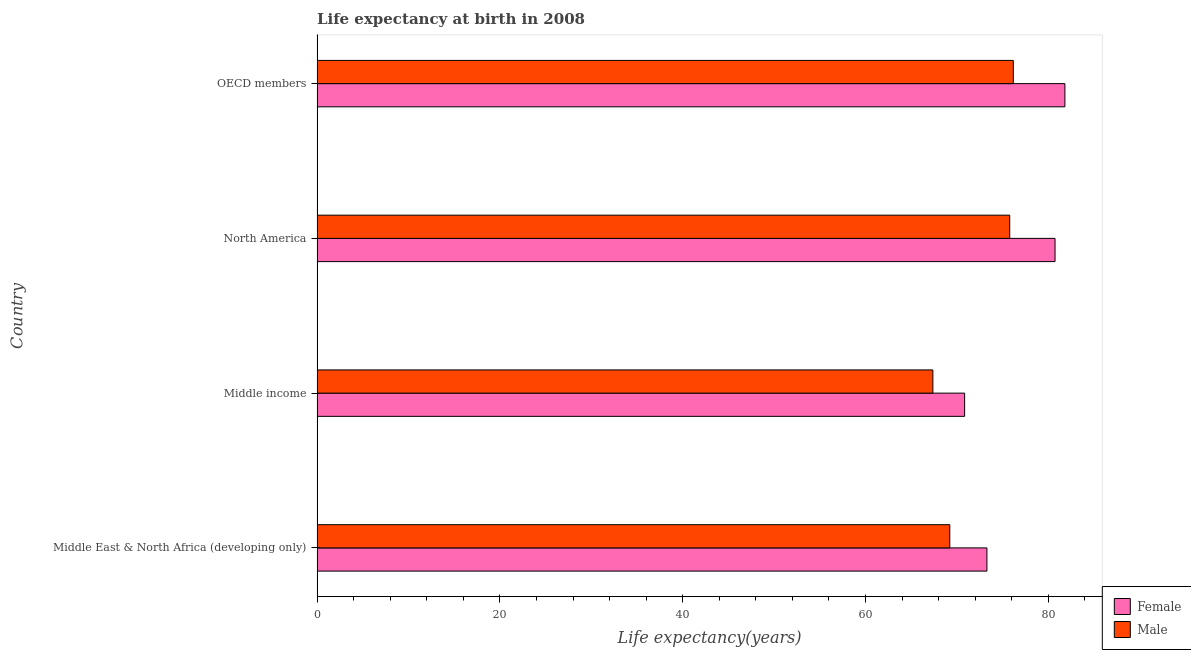How many different coloured bars are there?
Your response must be concise. 2. What is the label of the 2nd group of bars from the top?
Your answer should be very brief. North America. In how many cases, is the number of bars for a given country not equal to the number of legend labels?
Keep it short and to the point. 0. What is the life expectancy(male) in North America?
Your answer should be very brief. 75.78. Across all countries, what is the maximum life expectancy(male)?
Provide a succinct answer. 76.17. Across all countries, what is the minimum life expectancy(female)?
Ensure brevity in your answer.  70.84. In which country was the life expectancy(female) maximum?
Offer a very short reply. OECD members. In which country was the life expectancy(female) minimum?
Ensure brevity in your answer.  Middle income. What is the total life expectancy(female) in the graph?
Ensure brevity in your answer.  306.67. What is the difference between the life expectancy(male) in North America and that in OECD members?
Give a very brief answer. -0.39. What is the difference between the life expectancy(female) in OECD members and the life expectancy(male) in North America?
Your answer should be compact. 6.04. What is the average life expectancy(female) per country?
Ensure brevity in your answer.  76.67. What is the difference between the life expectancy(male) and life expectancy(female) in OECD members?
Keep it short and to the point. -5.65. In how many countries, is the life expectancy(female) greater than 36 years?
Your answer should be very brief. 4. What is the ratio of the life expectancy(male) in Middle income to that in OECD members?
Ensure brevity in your answer.  0.88. Is the life expectancy(male) in Middle East & North Africa (developing only) less than that in Middle income?
Offer a very short reply. No. What is the difference between the highest and the second highest life expectancy(male)?
Your response must be concise. 0.39. What does the 1st bar from the top in Middle income represents?
Make the answer very short. Male. Are all the bars in the graph horizontal?
Your answer should be compact. Yes. How many countries are there in the graph?
Offer a terse response. 4. Are the values on the major ticks of X-axis written in scientific E-notation?
Make the answer very short. No. Does the graph contain grids?
Your answer should be very brief. No. Where does the legend appear in the graph?
Make the answer very short. Bottom right. How many legend labels are there?
Provide a short and direct response. 2. What is the title of the graph?
Your answer should be compact. Life expectancy at birth in 2008. What is the label or title of the X-axis?
Offer a very short reply. Life expectancy(years). What is the Life expectancy(years) in Female in Middle East & North Africa (developing only)?
Provide a succinct answer. 73.28. What is the Life expectancy(years) in Male in Middle East & North Africa (developing only)?
Provide a succinct answer. 69.22. What is the Life expectancy(years) in Female in Middle income?
Your response must be concise. 70.84. What is the Life expectancy(years) of Male in Middle income?
Offer a terse response. 67.37. What is the Life expectancy(years) of Female in North America?
Ensure brevity in your answer.  80.73. What is the Life expectancy(years) in Male in North America?
Ensure brevity in your answer.  75.78. What is the Life expectancy(years) of Female in OECD members?
Offer a very short reply. 81.81. What is the Life expectancy(years) of Male in OECD members?
Your response must be concise. 76.17. Across all countries, what is the maximum Life expectancy(years) in Female?
Your answer should be very brief. 81.81. Across all countries, what is the maximum Life expectancy(years) in Male?
Make the answer very short. 76.17. Across all countries, what is the minimum Life expectancy(years) of Female?
Ensure brevity in your answer.  70.84. Across all countries, what is the minimum Life expectancy(years) of Male?
Your answer should be very brief. 67.37. What is the total Life expectancy(years) of Female in the graph?
Make the answer very short. 306.67. What is the total Life expectancy(years) in Male in the graph?
Your answer should be compact. 288.54. What is the difference between the Life expectancy(years) of Female in Middle East & North Africa (developing only) and that in Middle income?
Your answer should be very brief. 2.44. What is the difference between the Life expectancy(years) of Male in Middle East & North Africa (developing only) and that in Middle income?
Provide a short and direct response. 1.85. What is the difference between the Life expectancy(years) in Female in Middle East & North Africa (developing only) and that in North America?
Your answer should be compact. -7.45. What is the difference between the Life expectancy(years) of Male in Middle East & North Africa (developing only) and that in North America?
Keep it short and to the point. -6.56. What is the difference between the Life expectancy(years) of Female in Middle East & North Africa (developing only) and that in OECD members?
Keep it short and to the point. -8.53. What is the difference between the Life expectancy(years) of Male in Middle East & North Africa (developing only) and that in OECD members?
Ensure brevity in your answer.  -6.95. What is the difference between the Life expectancy(years) of Female in Middle income and that in North America?
Your answer should be very brief. -9.89. What is the difference between the Life expectancy(years) of Male in Middle income and that in North America?
Your answer should be compact. -8.41. What is the difference between the Life expectancy(years) in Female in Middle income and that in OECD members?
Offer a terse response. -10.97. What is the difference between the Life expectancy(years) in Male in Middle income and that in OECD members?
Provide a succinct answer. -8.8. What is the difference between the Life expectancy(years) in Female in North America and that in OECD members?
Your answer should be compact. -1.08. What is the difference between the Life expectancy(years) in Male in North America and that in OECD members?
Your answer should be compact. -0.39. What is the difference between the Life expectancy(years) in Female in Middle East & North Africa (developing only) and the Life expectancy(years) in Male in Middle income?
Make the answer very short. 5.91. What is the difference between the Life expectancy(years) of Female in Middle East & North Africa (developing only) and the Life expectancy(years) of Male in North America?
Provide a succinct answer. -2.5. What is the difference between the Life expectancy(years) in Female in Middle East & North Africa (developing only) and the Life expectancy(years) in Male in OECD members?
Your answer should be compact. -2.89. What is the difference between the Life expectancy(years) in Female in Middle income and the Life expectancy(years) in Male in North America?
Your answer should be very brief. -4.94. What is the difference between the Life expectancy(years) in Female in Middle income and the Life expectancy(years) in Male in OECD members?
Offer a terse response. -5.33. What is the difference between the Life expectancy(years) in Female in North America and the Life expectancy(years) in Male in OECD members?
Make the answer very short. 4.57. What is the average Life expectancy(years) of Female per country?
Offer a very short reply. 76.67. What is the average Life expectancy(years) of Male per country?
Provide a succinct answer. 72.13. What is the difference between the Life expectancy(years) in Female and Life expectancy(years) in Male in Middle East & North Africa (developing only)?
Give a very brief answer. 4.06. What is the difference between the Life expectancy(years) of Female and Life expectancy(years) of Male in Middle income?
Ensure brevity in your answer.  3.47. What is the difference between the Life expectancy(years) in Female and Life expectancy(years) in Male in North America?
Give a very brief answer. 4.96. What is the difference between the Life expectancy(years) of Female and Life expectancy(years) of Male in OECD members?
Your response must be concise. 5.65. What is the ratio of the Life expectancy(years) in Female in Middle East & North Africa (developing only) to that in Middle income?
Make the answer very short. 1.03. What is the ratio of the Life expectancy(years) in Male in Middle East & North Africa (developing only) to that in Middle income?
Your response must be concise. 1.03. What is the ratio of the Life expectancy(years) of Female in Middle East & North Africa (developing only) to that in North America?
Your answer should be very brief. 0.91. What is the ratio of the Life expectancy(years) of Male in Middle East & North Africa (developing only) to that in North America?
Keep it short and to the point. 0.91. What is the ratio of the Life expectancy(years) in Female in Middle East & North Africa (developing only) to that in OECD members?
Provide a short and direct response. 0.9. What is the ratio of the Life expectancy(years) in Male in Middle East & North Africa (developing only) to that in OECD members?
Ensure brevity in your answer.  0.91. What is the ratio of the Life expectancy(years) in Female in Middle income to that in North America?
Offer a very short reply. 0.88. What is the ratio of the Life expectancy(years) of Male in Middle income to that in North America?
Your response must be concise. 0.89. What is the ratio of the Life expectancy(years) in Female in Middle income to that in OECD members?
Your answer should be very brief. 0.87. What is the ratio of the Life expectancy(years) in Male in Middle income to that in OECD members?
Give a very brief answer. 0.88. What is the ratio of the Life expectancy(years) in Female in North America to that in OECD members?
Make the answer very short. 0.99. What is the difference between the highest and the second highest Life expectancy(years) in Male?
Ensure brevity in your answer.  0.39. What is the difference between the highest and the lowest Life expectancy(years) in Female?
Offer a terse response. 10.97. What is the difference between the highest and the lowest Life expectancy(years) in Male?
Ensure brevity in your answer.  8.8. 